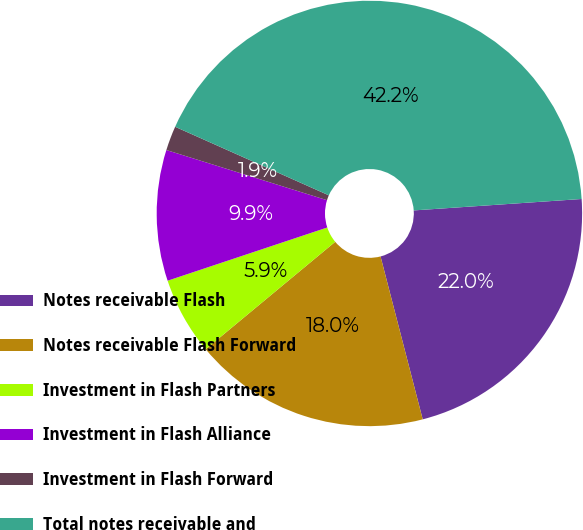<chart> <loc_0><loc_0><loc_500><loc_500><pie_chart><fcel>Notes receivable Flash<fcel>Notes receivable Flash Forward<fcel>Investment in Flash Partners<fcel>Investment in Flash Alliance<fcel>Investment in Flash Forward<fcel>Total notes receivable and<nl><fcel>22.05%<fcel>18.01%<fcel>5.9%<fcel>9.94%<fcel>1.86%<fcel>42.24%<nl></chart> 